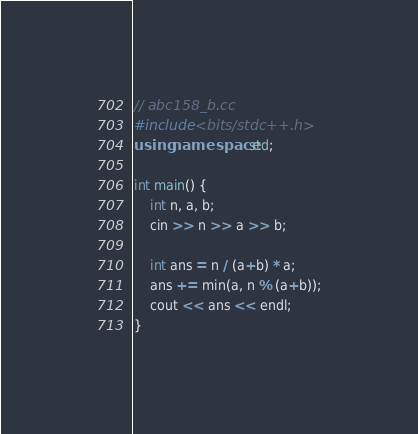<code> <loc_0><loc_0><loc_500><loc_500><_C++_>// abc158_b.cc
#include <bits/stdc++.h>
using namespace std;

int main() {
	int n, a, b;
	cin >> n >> a >> b;

	int ans = n / (a+b) * a;
	ans += min(a, n % (a+b));
	cout << ans << endl;
}</code> 